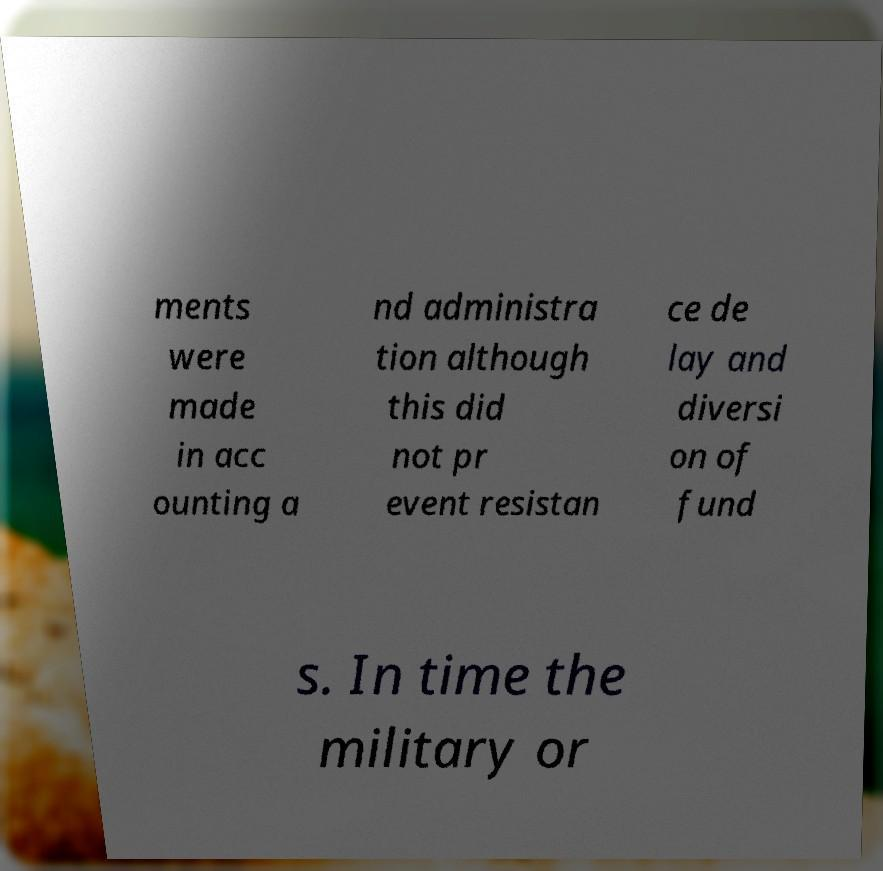Can you accurately transcribe the text from the provided image for me? ments were made in acc ounting a nd administra tion although this did not pr event resistan ce de lay and diversi on of fund s. In time the military or 